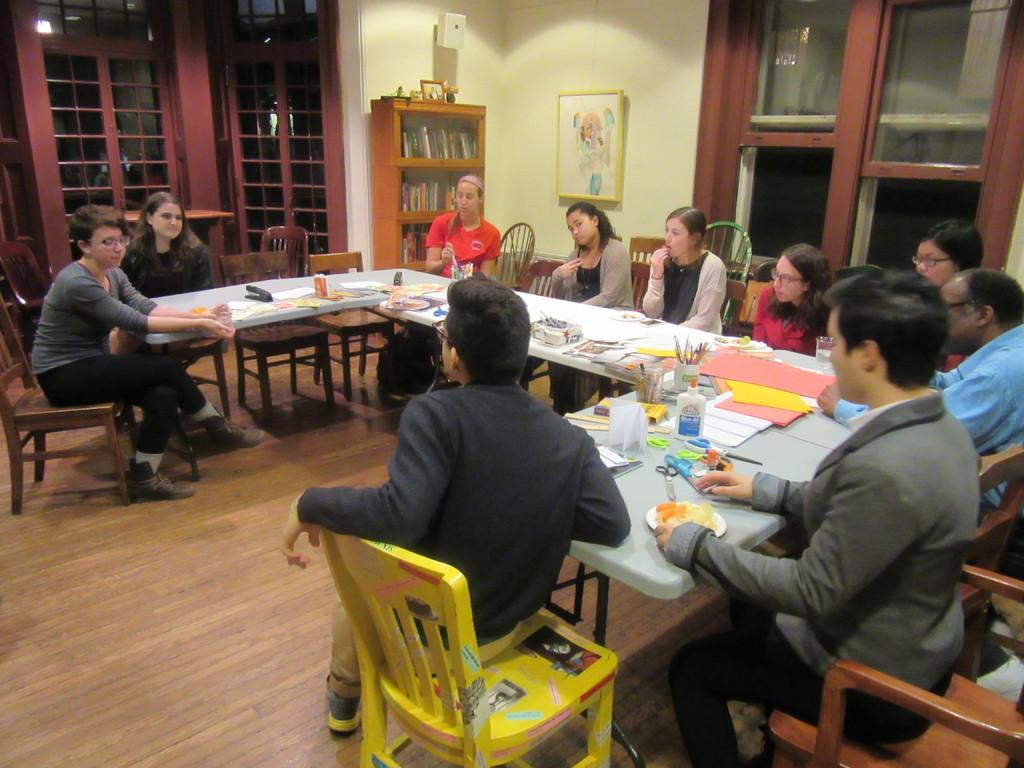Could you give a brief overview of what you see in this image? This is a picture in a room. In the center of the image there is a desk, on the desk there are pens, papers, scissors, scales. In this room there are a lot of chairs. There are many people seated around the desk. On the top right there is a window. In the background there is a frame and a closet. On the top left there is a door. There is a wooden floor on the bottom. 